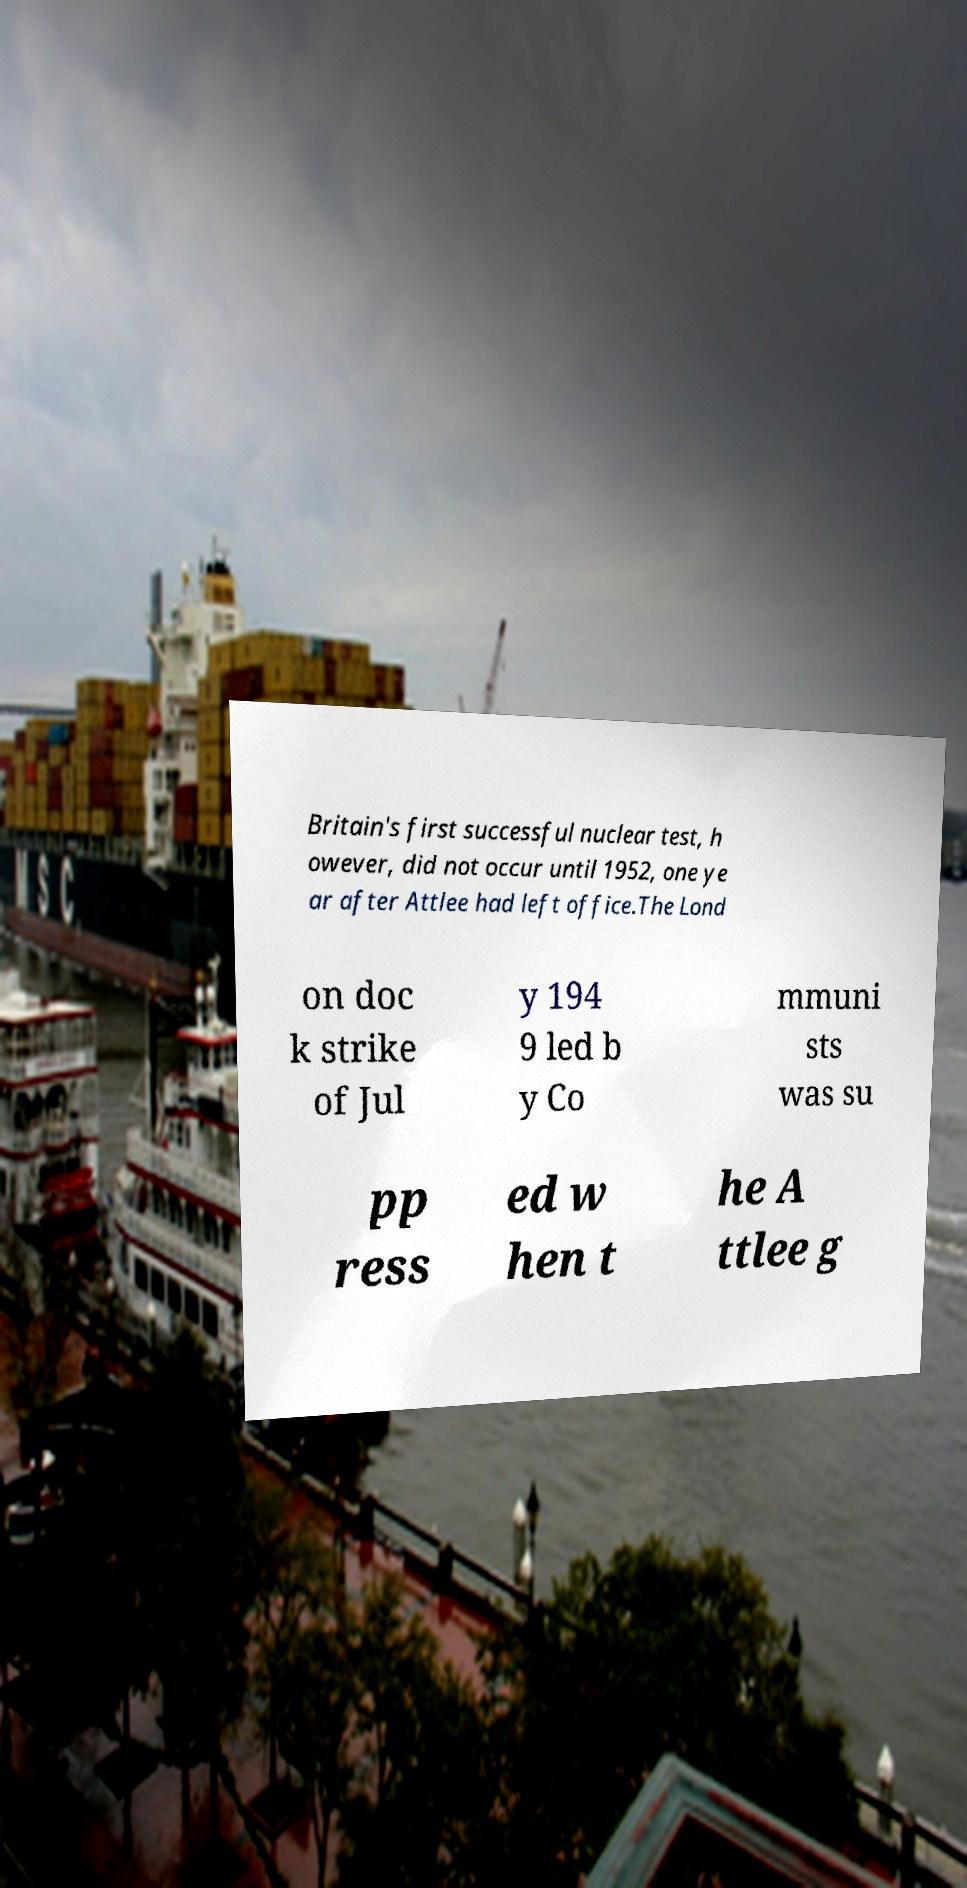Please identify and transcribe the text found in this image. Britain's first successful nuclear test, h owever, did not occur until 1952, one ye ar after Attlee had left office.The Lond on doc k strike of Jul y 194 9 led b y Co mmuni sts was su pp ress ed w hen t he A ttlee g 